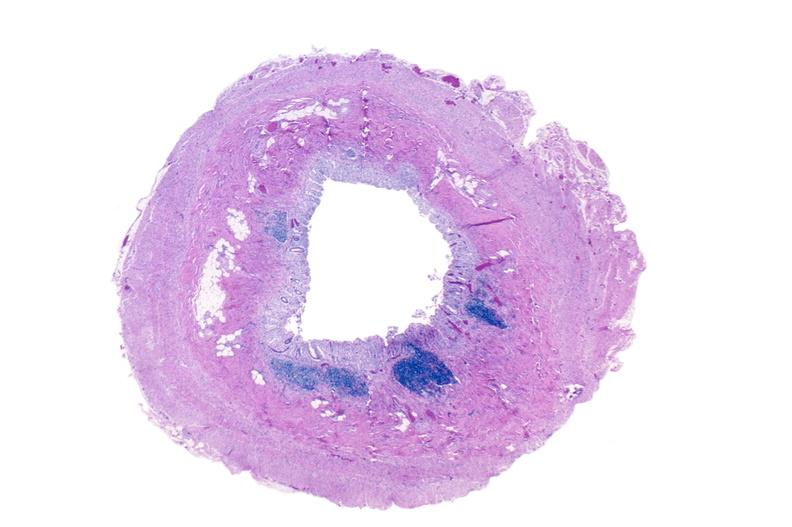where is this from?
Answer the question using a single word or phrase. Gastrointestinal system 